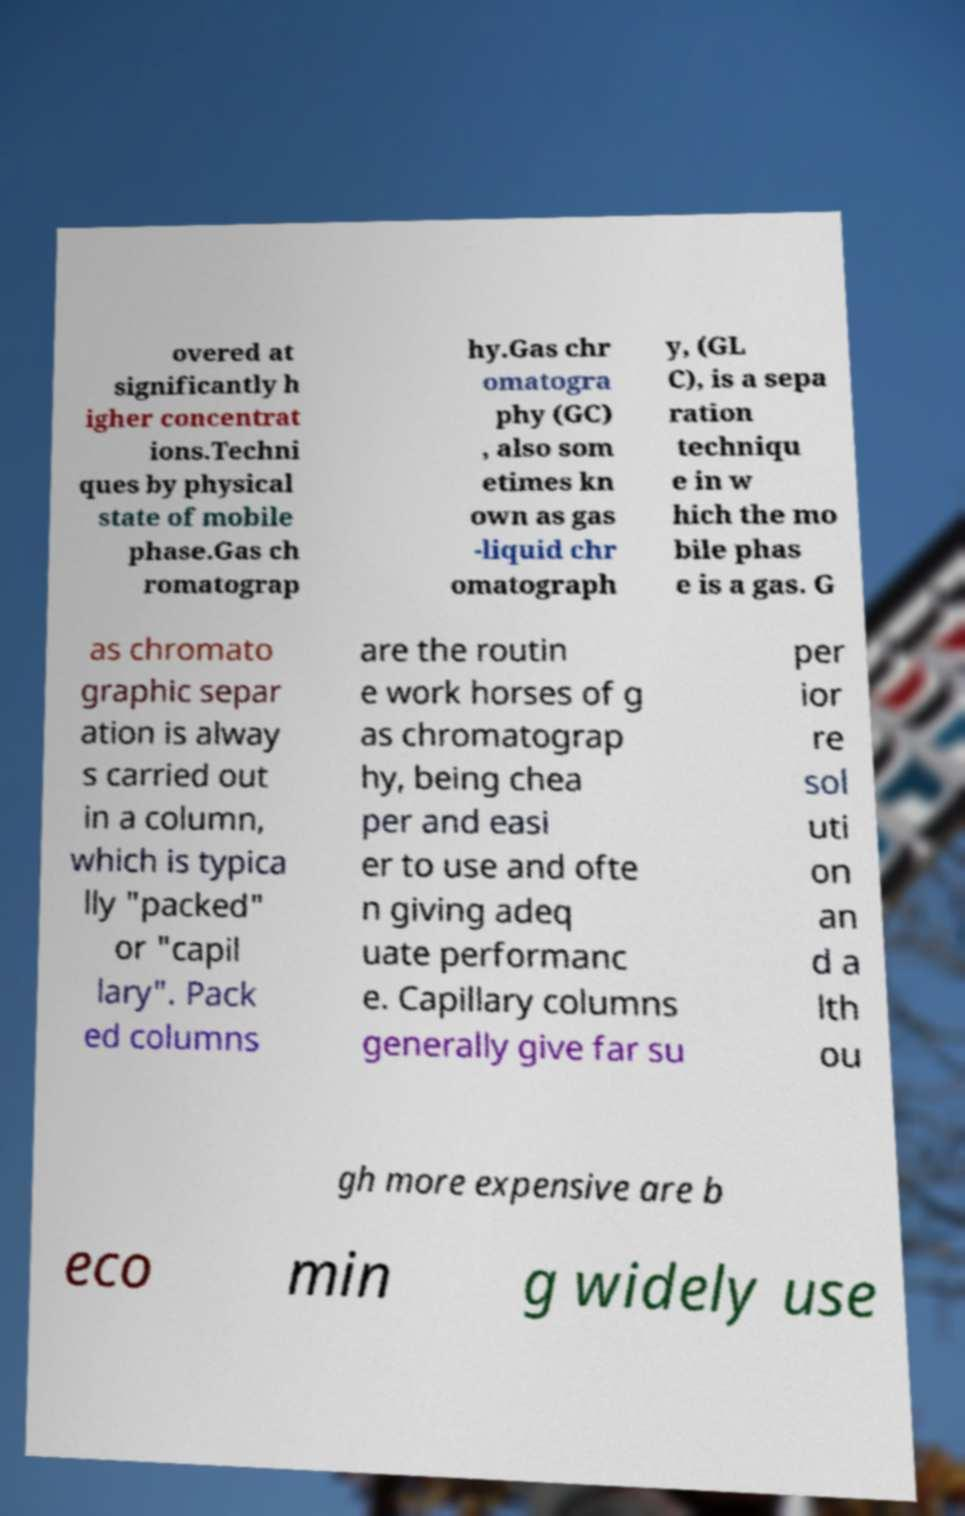Could you assist in decoding the text presented in this image and type it out clearly? overed at significantly h igher concentrat ions.Techni ques by physical state of mobile phase.Gas ch romatograp hy.Gas chr omatogra phy (GC) , also som etimes kn own as gas -liquid chr omatograph y, (GL C), is a sepa ration techniqu e in w hich the mo bile phas e is a gas. G as chromato graphic separ ation is alway s carried out in a column, which is typica lly "packed" or "capil lary". Pack ed columns are the routin e work horses of g as chromatograp hy, being chea per and easi er to use and ofte n giving adeq uate performanc e. Capillary columns generally give far su per ior re sol uti on an d a lth ou gh more expensive are b eco min g widely use 